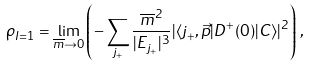<formula> <loc_0><loc_0><loc_500><loc_500>\rho _ { I = 1 } = \lim _ { \overline { m } \to 0 } \left ( - \sum _ { j _ { + } } \frac { \overline { m } ^ { 2 } } { | E _ { j _ { + } } | ^ { 3 } } | \langle j _ { + } , \vec { p } | D ^ { + } ( 0 ) | C \rangle | ^ { 2 } \right ) \, ,</formula> 